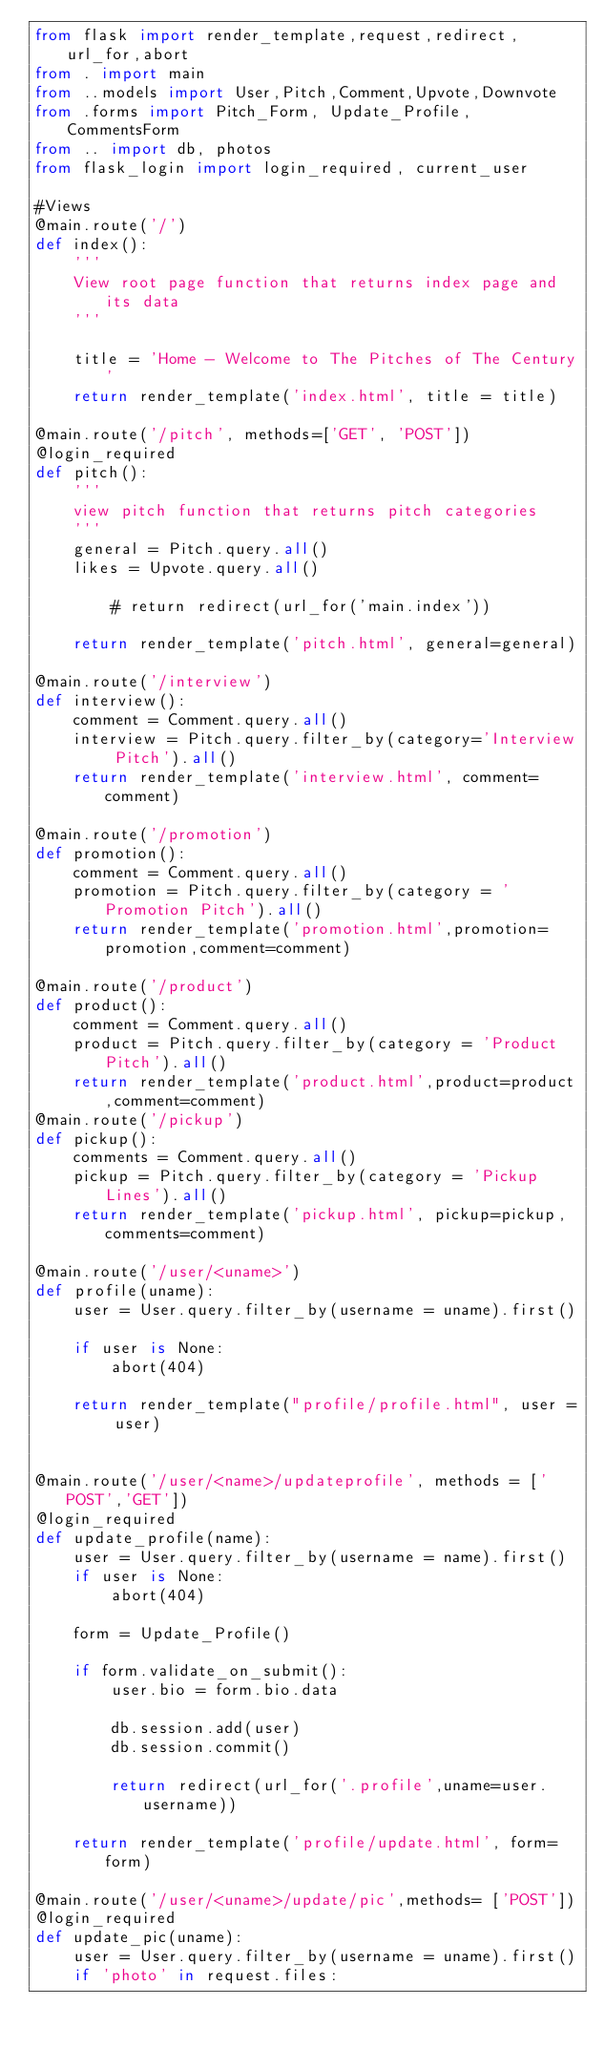Convert code to text. <code><loc_0><loc_0><loc_500><loc_500><_Python_>from flask import render_template,request,redirect,url_for,abort
from . import main
from ..models import User,Pitch,Comment,Upvote,Downvote
from .forms import Pitch_Form, Update_Profile,CommentsForm
from .. import db, photos
from flask_login import login_required, current_user

#Views
@main.route('/')
def index():
    '''
    View root page function that returns index page and its data
    '''

    title = 'Home - Welcome to The Pitches of The Century'
    return render_template('index.html', title = title)
    
@main.route('/pitch', methods=['GET', 'POST'])
@login_required
def pitch():
    '''
    view pitch function that returns pitch categories
    '''
    general = Pitch.query.all()
    likes = Upvote.query.all()

        # return redirect(url_for('main.index'))

    return render_template('pitch.html', general=general)
    
@main.route('/interview')
def interview():
    comment = Comment.query.all()
    interview = Pitch.query.filter_by(category='Interview Pitch').all()
    return render_template('interview.html', comment=comment)

@main.route('/promotion')
def promotion():
    comment = Comment.query.all()
    promotion = Pitch.query.filter_by(category = 'Promotion Pitch').all()
    return render_template('promotion.html',promotion=promotion,comment=comment)

@main.route('/product')
def product():
    comment = Comment.query.all()
    product = Pitch.query.filter_by(category = 'Product Pitch').all()
    return render_template('product.html',product=product,comment=comment)
@main.route('/pickup')
def pickup():
    comments = Comment.query.all()
    pickup = Pitch.query.filter_by(category = 'Pickup Lines').all()
    return render_template('pickup.html', pickup=pickup,comments=comment)        
    
@main.route('/user/<uname>')
def profile(uname):
    user = User.query.filter_by(username = uname).first()

    if user is None:
        abort(404)

    return render_template("profile/profile.html", user = user)


@main.route('/user/<name>/updateprofile', methods = ['POST','GET'])
@login_required
def update_profile(name):
    user = User.query.filter_by(username = name).first()
    if user is None:
        abort(404)

    form = Update_Profile()

    if form.validate_on_submit():
        user.bio = form.bio.data

        db.session.add(user)
        db.session.commit()

        return redirect(url_for('.profile',uname=user.username))

    return render_template('profile/update.html', form=form)
    
@main.route('/user/<uname>/update/pic',methods= ['POST'])
@login_required
def update_pic(uname):
    user = User.query.filter_by(username = uname).first()
    if 'photo' in request.files:</code> 